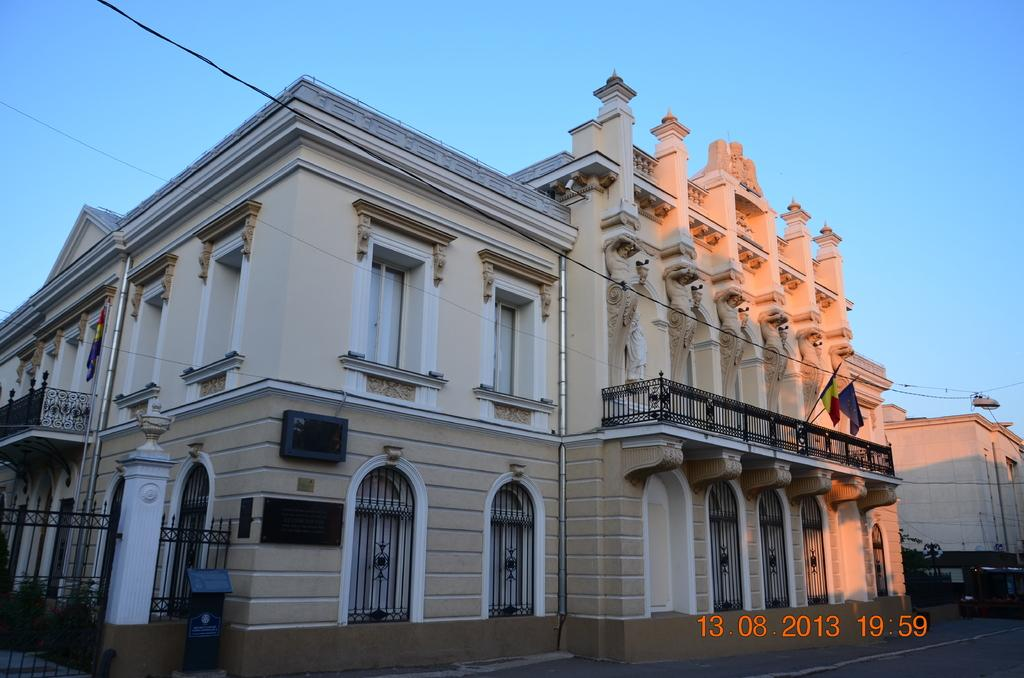What is the main subject in the foreground of the image? There is a building in the foreground of the image. Can you provide any additional information about the building? Unfortunately, the provided facts do not offer any further details about the building. Is there any text or numbers visible in the image? Yes, there is date and time information at the bottom right corner of the image. How many rakes are leaning against the building in the image? There are no rakes visible in the image; it only features a building and date and time information. What type of earth can be seen surrounding the building in the image? The provided facts do not mention any earth or ground surrounding the building, so it cannot be determined from the image. 